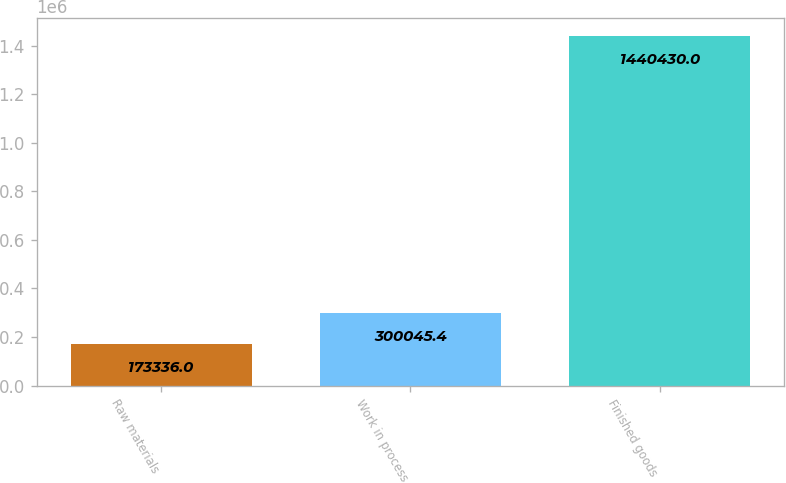<chart> <loc_0><loc_0><loc_500><loc_500><bar_chart><fcel>Raw materials<fcel>Work in process<fcel>Finished goods<nl><fcel>173336<fcel>300045<fcel>1.44043e+06<nl></chart> 